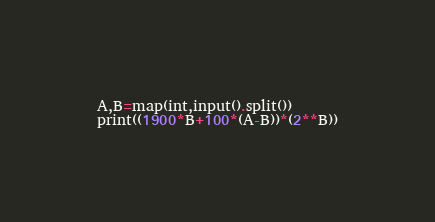Convert code to text. <code><loc_0><loc_0><loc_500><loc_500><_Python_>A,B=map(int,input().split())
print((1900*B+100*(A-B))*(2**B))</code> 